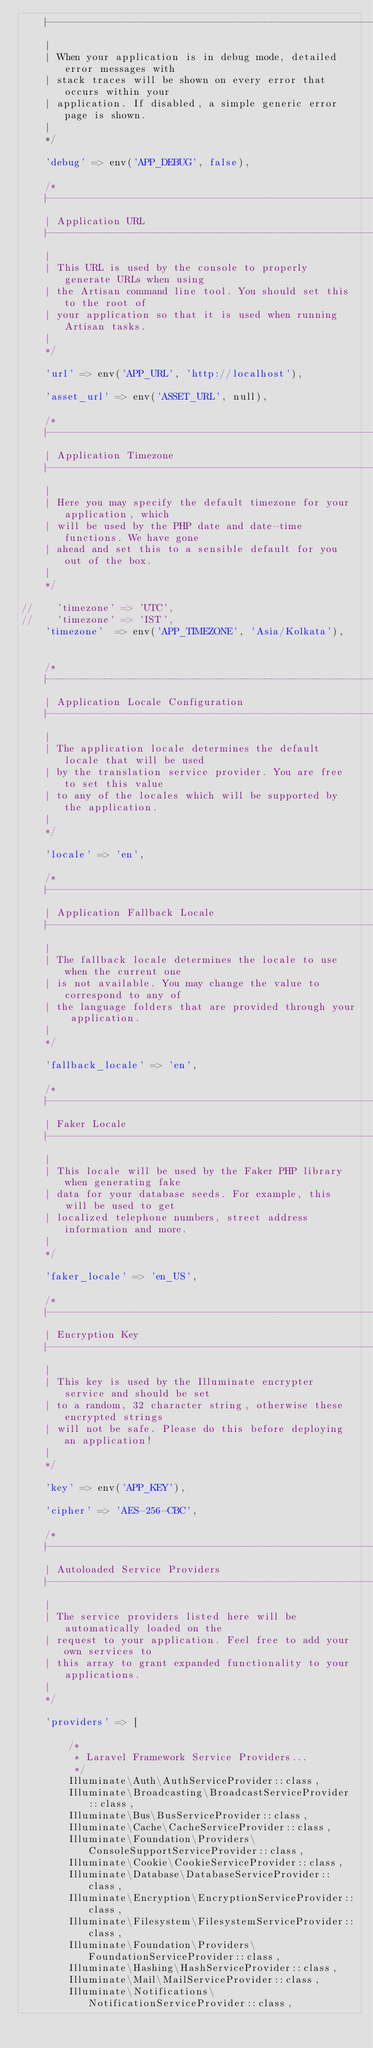Convert code to text. <code><loc_0><loc_0><loc_500><loc_500><_PHP_>    |--------------------------------------------------------------------------
    |
    | When your application is in debug mode, detailed error messages with
    | stack traces will be shown on every error that occurs within your
    | application. If disabled, a simple generic error page is shown.
    |
    */

    'debug' => env('APP_DEBUG', false),

    /*
    |--------------------------------------------------------------------------
    | Application URL
    |--------------------------------------------------------------------------
    |
    | This URL is used by the console to properly generate URLs when using
    | the Artisan command line tool. You should set this to the root of
    | your application so that it is used when running Artisan tasks.
    |
    */

    'url' => env('APP_URL', 'http://localhost'),

    'asset_url' => env('ASSET_URL', null),

    /*
    |--------------------------------------------------------------------------
    | Application Timezone
    |--------------------------------------------------------------------------
    |
    | Here you may specify the default timezone for your application, which
    | will be used by the PHP date and date-time functions. We have gone
    | ahead and set this to a sensible default for you out of the box.
    |
    */

//    'timezone' => 'UTC',
//    'timezone' => 'IST',
    'timezone'  => env('APP_TIMEZONE', 'Asia/Kolkata'),


    /*
    |--------------------------------------------------------------------------
    | Application Locale Configuration
    |--------------------------------------------------------------------------
    |
    | The application locale determines the default locale that will be used
    | by the translation service provider. You are free to set this value
    | to any of the locales which will be supported by the application.
    |
    */

    'locale' => 'en',

    /*
    |--------------------------------------------------------------------------
    | Application Fallback Locale
    |--------------------------------------------------------------------------
    |
    | The fallback locale determines the locale to use when the current one
    | is not available. You may change the value to correspond to any of
    | the language folders that are provided through your application.
    |
    */

    'fallback_locale' => 'en',

    /*
    |--------------------------------------------------------------------------
    | Faker Locale
    |--------------------------------------------------------------------------
    |
    | This locale will be used by the Faker PHP library when generating fake
    | data for your database seeds. For example, this will be used to get
    | localized telephone numbers, street address information and more.
    |
    */

    'faker_locale' => 'en_US',

    /*
    |--------------------------------------------------------------------------
    | Encryption Key
    |--------------------------------------------------------------------------
    |
    | This key is used by the Illuminate encrypter service and should be set
    | to a random, 32 character string, otherwise these encrypted strings
    | will not be safe. Please do this before deploying an application!
    |
    */

    'key' => env('APP_KEY'),

    'cipher' => 'AES-256-CBC',

    /*
    |--------------------------------------------------------------------------
    | Autoloaded Service Providers
    |--------------------------------------------------------------------------
    |
    | The service providers listed here will be automatically loaded on the
    | request to your application. Feel free to add your own services to
    | this array to grant expanded functionality to your applications.
    |
    */

    'providers' => [

        /*
         * Laravel Framework Service Providers...
         */
        Illuminate\Auth\AuthServiceProvider::class,
        Illuminate\Broadcasting\BroadcastServiceProvider::class,
        Illuminate\Bus\BusServiceProvider::class,
        Illuminate\Cache\CacheServiceProvider::class,
        Illuminate\Foundation\Providers\ConsoleSupportServiceProvider::class,
        Illuminate\Cookie\CookieServiceProvider::class,
        Illuminate\Database\DatabaseServiceProvider::class,
        Illuminate\Encryption\EncryptionServiceProvider::class,
        Illuminate\Filesystem\FilesystemServiceProvider::class,
        Illuminate\Foundation\Providers\FoundationServiceProvider::class,
        Illuminate\Hashing\HashServiceProvider::class,
        Illuminate\Mail\MailServiceProvider::class,
        Illuminate\Notifications\NotificationServiceProvider::class,</code> 